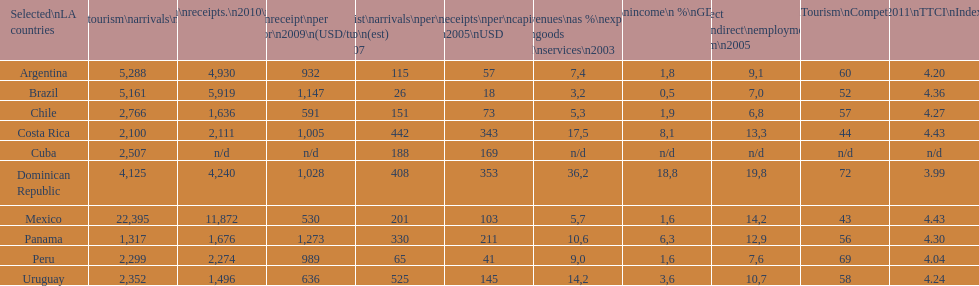Give me the full table as a dictionary. {'header': ['Selected\\nLA countries', 'Internl.\\ntourism\\narrivals\\n2010\\n(x 1000)', 'Internl.\\ntourism\\nreceipts.\\n2010\\n(USD\\n(x1000)', 'Avg\\nreceipt\\nper visitor\\n2009\\n(USD/turista)', 'Tourist\\narrivals\\nper\\n1000 inhab\\n(est) \\n2007', 'Receipts\\nper\\ncapita \\n2005\\nUSD', 'Revenues\\nas\xa0%\\nexports of\\ngoods and\\nservices\\n2003', 'Tourism\\nincome\\n\xa0%\\nGDP\\n2003', '% Direct and\\nindirect\\nemployment\\nin tourism\\n2005', 'World\\nranking\\nTourism\\nCompetitiv.\\nTTCI\\n2011', '2011\\nTTCI\\nIndex'], 'rows': [['Argentina', '5,288', '4,930', '932', '115', '57', '7,4', '1,8', '9,1', '60', '4.20'], ['Brazil', '5,161', '5,919', '1,147', '26', '18', '3,2', '0,5', '7,0', '52', '4.36'], ['Chile', '2,766', '1,636', '591', '151', '73', '5,3', '1,9', '6,8', '57', '4.27'], ['Costa Rica', '2,100', '2,111', '1,005', '442', '343', '17,5', '8,1', '13,3', '44', '4.43'], ['Cuba', '2,507', 'n/d', 'n/d', '188', '169', 'n/d', 'n/d', 'n/d', 'n/d', 'n/d'], ['Dominican Republic', '4,125', '4,240', '1,028', '408', '353', '36,2', '18,8', '19,8', '72', '3.99'], ['Mexico', '22,395', '11,872', '530', '201', '103', '5,7', '1,6', '14,2', '43', '4.43'], ['Panama', '1,317', '1,676', '1,273', '330', '211', '10,6', '6,3', '12,9', '56', '4.30'], ['Peru', '2,299', '2,274', '989', '65', '41', '9,0', '1,6', '7,6', '69', '4.04'], ['Uruguay', '2,352', '1,496', '636', '525', '145', '14,2', '3,6', '10,7', '58', '4.24']]} What country makes the most tourist income? Dominican Republic. 